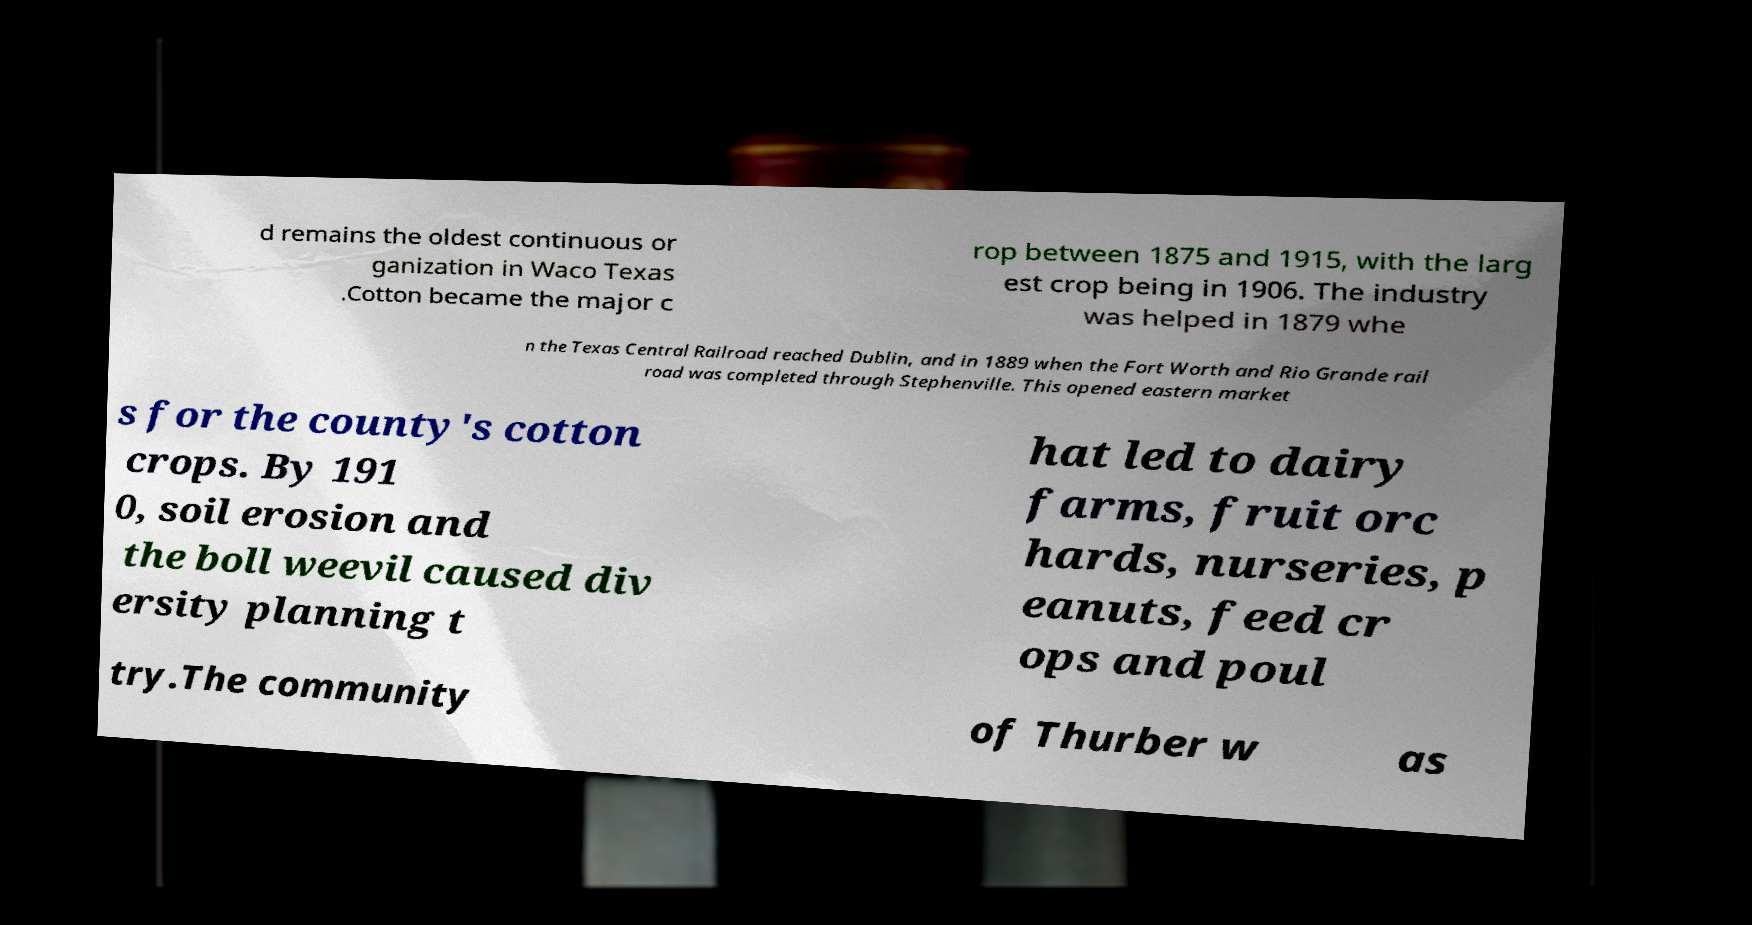What messages or text are displayed in this image? I need them in a readable, typed format. d remains the oldest continuous or ganization in Waco Texas .Cotton became the major c rop between 1875 and 1915, with the larg est crop being in 1906. The industry was helped in 1879 whe n the Texas Central Railroad reached Dublin, and in 1889 when the Fort Worth and Rio Grande rail road was completed through Stephenville. This opened eastern market s for the county's cotton crops. By 191 0, soil erosion and the boll weevil caused div ersity planning t hat led to dairy farms, fruit orc hards, nurseries, p eanuts, feed cr ops and poul try.The community of Thurber w as 